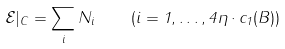Convert formula to latex. <formula><loc_0><loc_0><loc_500><loc_500>\mathcal { E } | _ { C } = \sum _ { i } N _ { i } \quad ( i = 1 , \dots , 4 \eta \cdot c _ { 1 } ( B ) )</formula> 